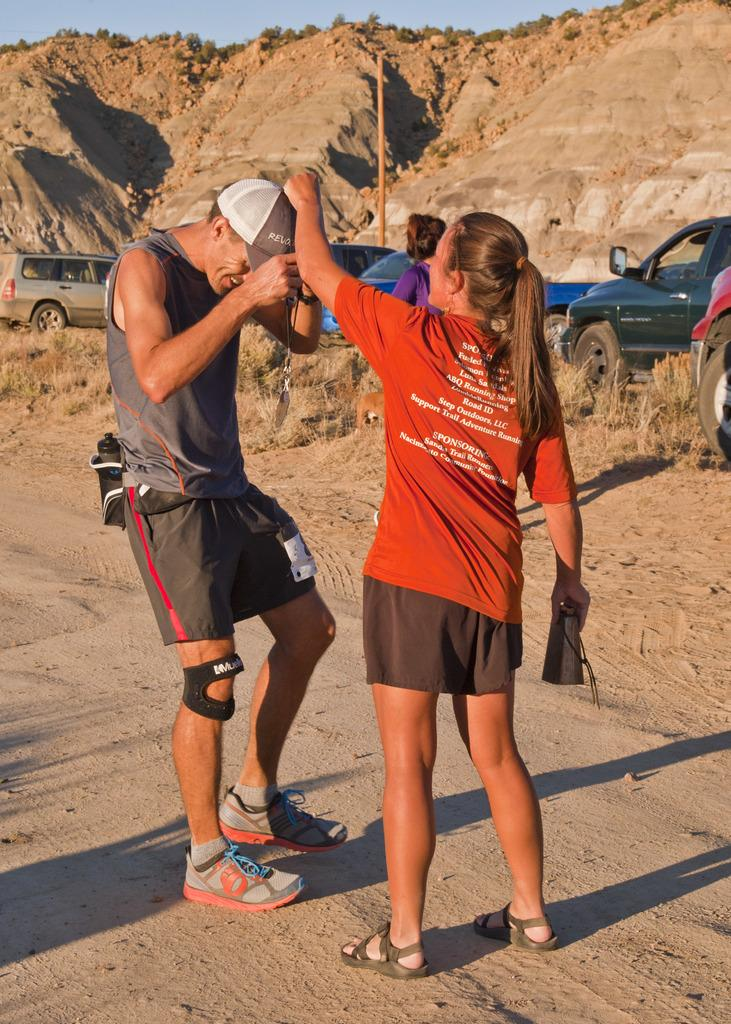What are the persons in the image doing? The persons in the image are standing and playing. What can be seen in the background of the image? There are cars on the road and a mountain visible in the background of the image. Can you describe a specific object in the image? Yes, there is a pole in the image. What grade did the person in the image receive on their last exam? There is no information about exams or grades in the image, as it focuses on persons standing and playing, cars on the road, a mountain, and a pole. 